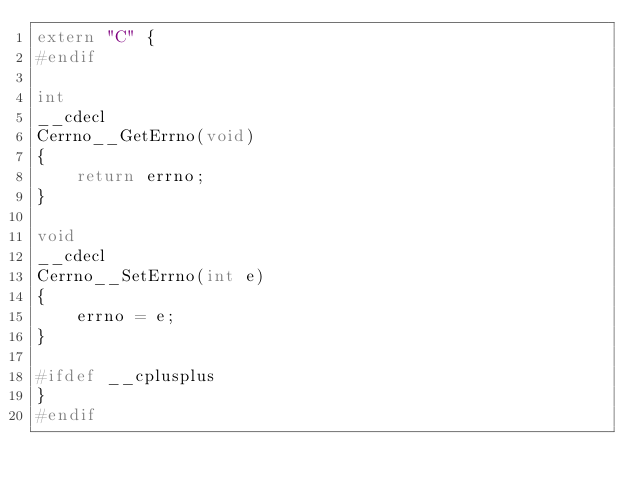<code> <loc_0><loc_0><loc_500><loc_500><_C_>extern "C" {
#endif

int
__cdecl
Cerrno__GetErrno(void)
{
    return errno;
}

void
__cdecl
Cerrno__SetErrno(int e)
{
    errno = e;
}

#ifdef __cplusplus
}
#endif
</code> 